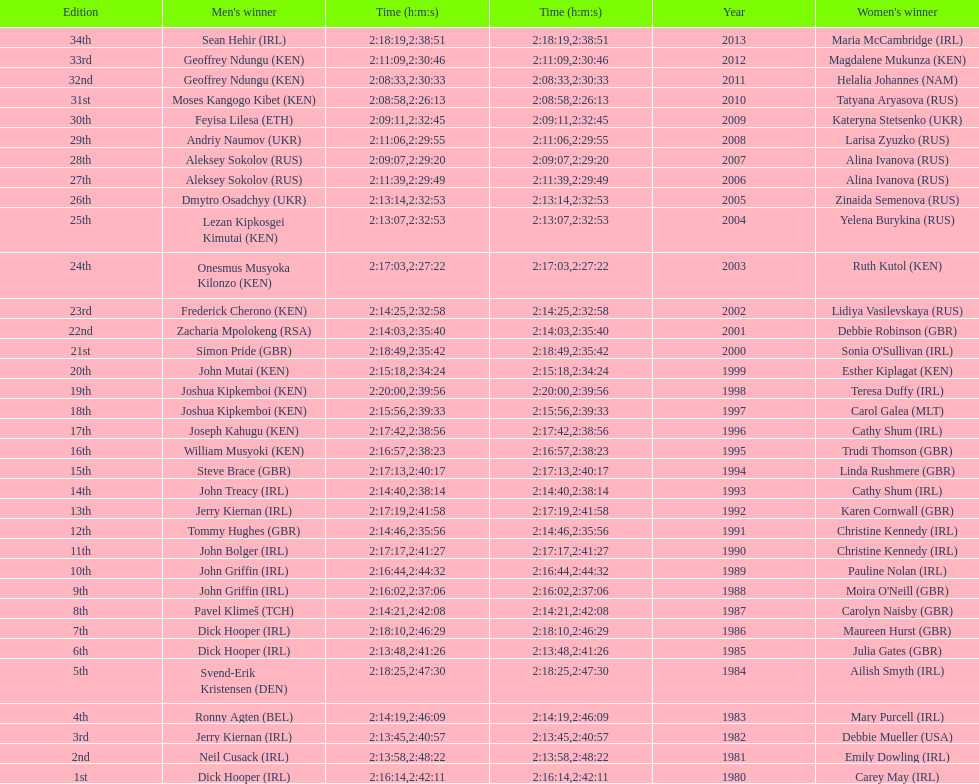Which country is represented for both men and women at the top of the list? Ireland. 